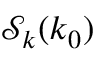<formula> <loc_0><loc_0><loc_500><loc_500>\mathcal { S } _ { k } ( k _ { 0 } )</formula> 